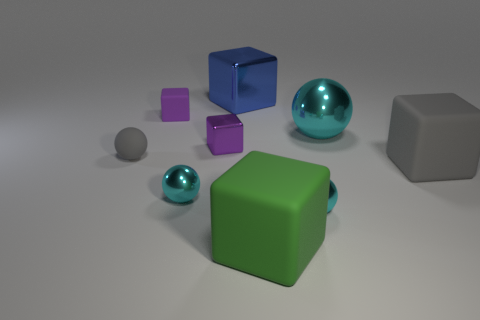How many purple blocks must be subtracted to get 1 purple blocks? 1 Subtract all yellow cubes. How many cyan balls are left? 3 Subtract all big green cubes. How many cubes are left? 4 Subtract all green blocks. How many blocks are left? 4 Subtract 1 balls. How many balls are left? 3 Subtract all brown blocks. Subtract all purple cylinders. How many blocks are left? 5 Subtract all balls. How many objects are left? 5 Add 6 big gray matte cubes. How many big gray matte cubes are left? 7 Add 4 tiny gray metal blocks. How many tiny gray metal blocks exist? 4 Subtract 0 green balls. How many objects are left? 9 